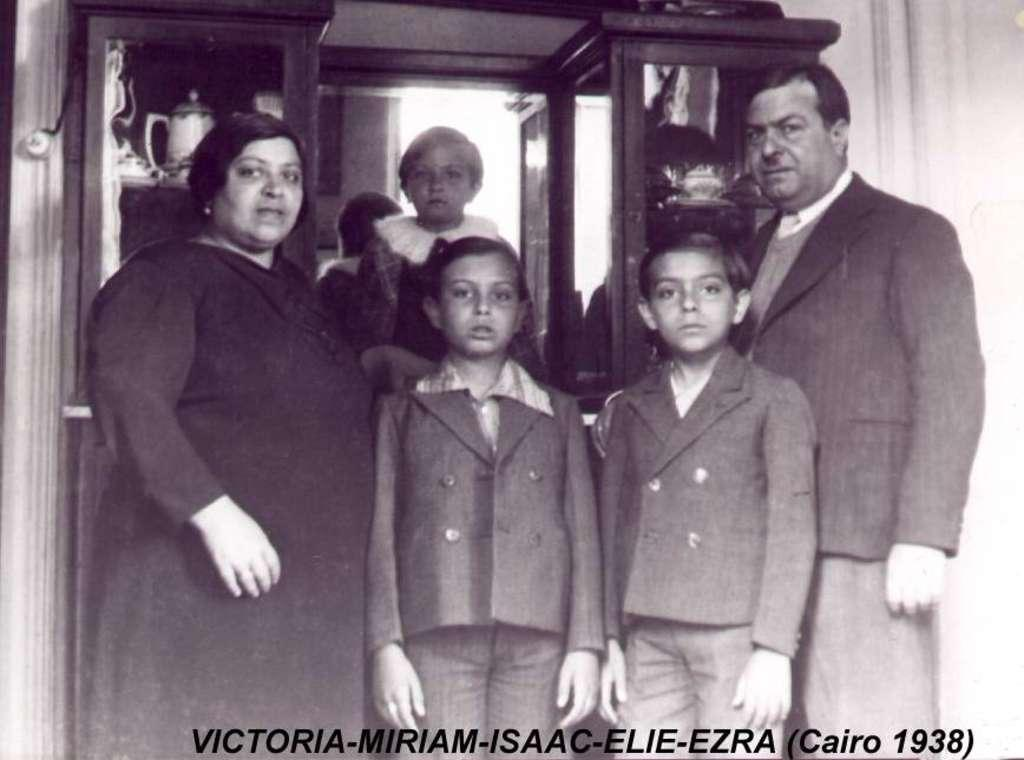What is happening in the image? There are people standing in the image. What can be seen in the background of the image? There are cupboards with items in the background of the image. Is there any text present in the image? Yes, there is text written at the bottom of the image. What is the color scheme of the image? The image is black and white. Can you see any rifles being used by the people in the image? There are no rifles present in the image. Are the people in the image jumping or performing any physical activity? The image does not show the people jumping or performing any physical activity; they are simply standing. 